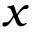Convert formula to latex. <formula><loc_0><loc_0><loc_500><loc_500>x</formula> 